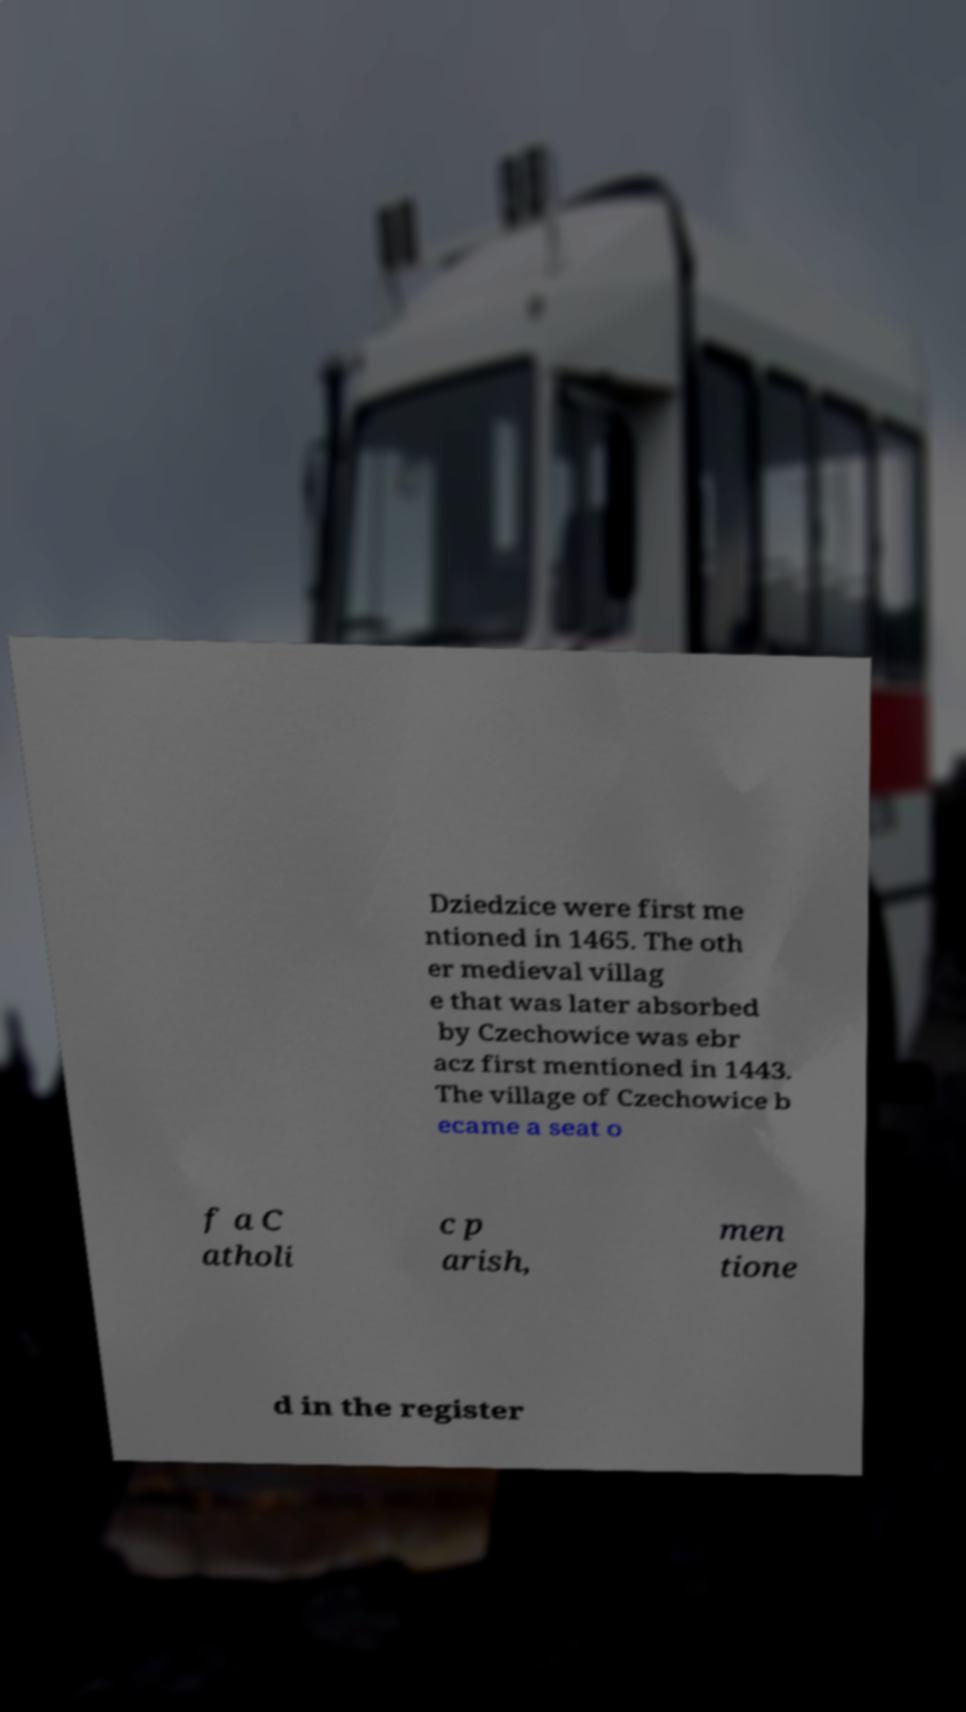I need the written content from this picture converted into text. Can you do that? Dziedzice were first me ntioned in 1465. The oth er medieval villag e that was later absorbed by Czechowice was ebr acz first mentioned in 1443. The village of Czechowice b ecame a seat o f a C atholi c p arish, men tione d in the register 